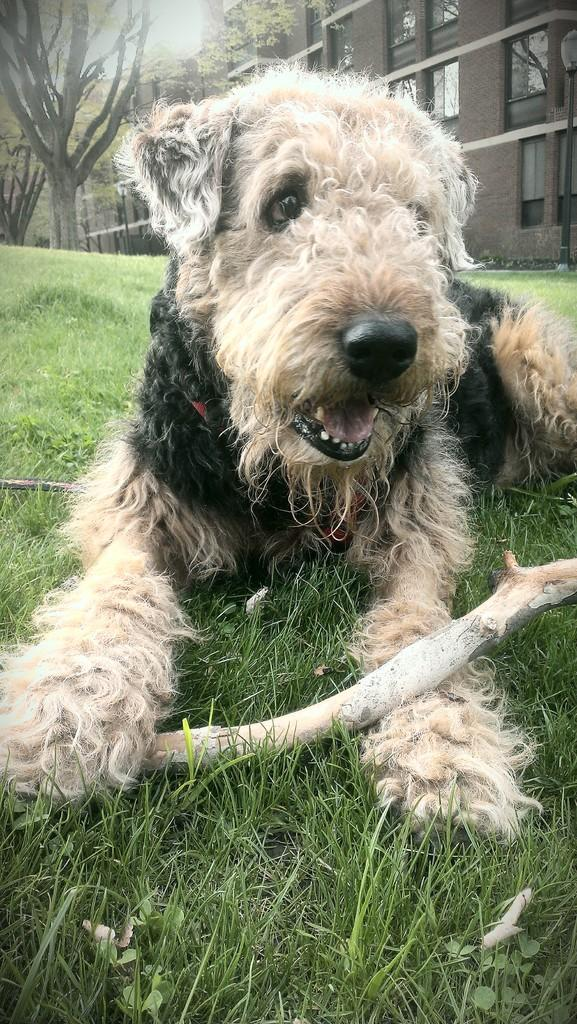What animal is present in the image? There is a dog in the image. What is the dog doing in the image? The dog is sitting on the ground. What can be seen in the background of the image? There is grass, trees, buildings, and other objects in the background of the image. What type of library can be seen in the background of the image? There is no library present in the image; the background features grass, trees, buildings, and other objects. 